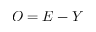Convert formula to latex. <formula><loc_0><loc_0><loc_500><loc_500>O = E - Y</formula> 